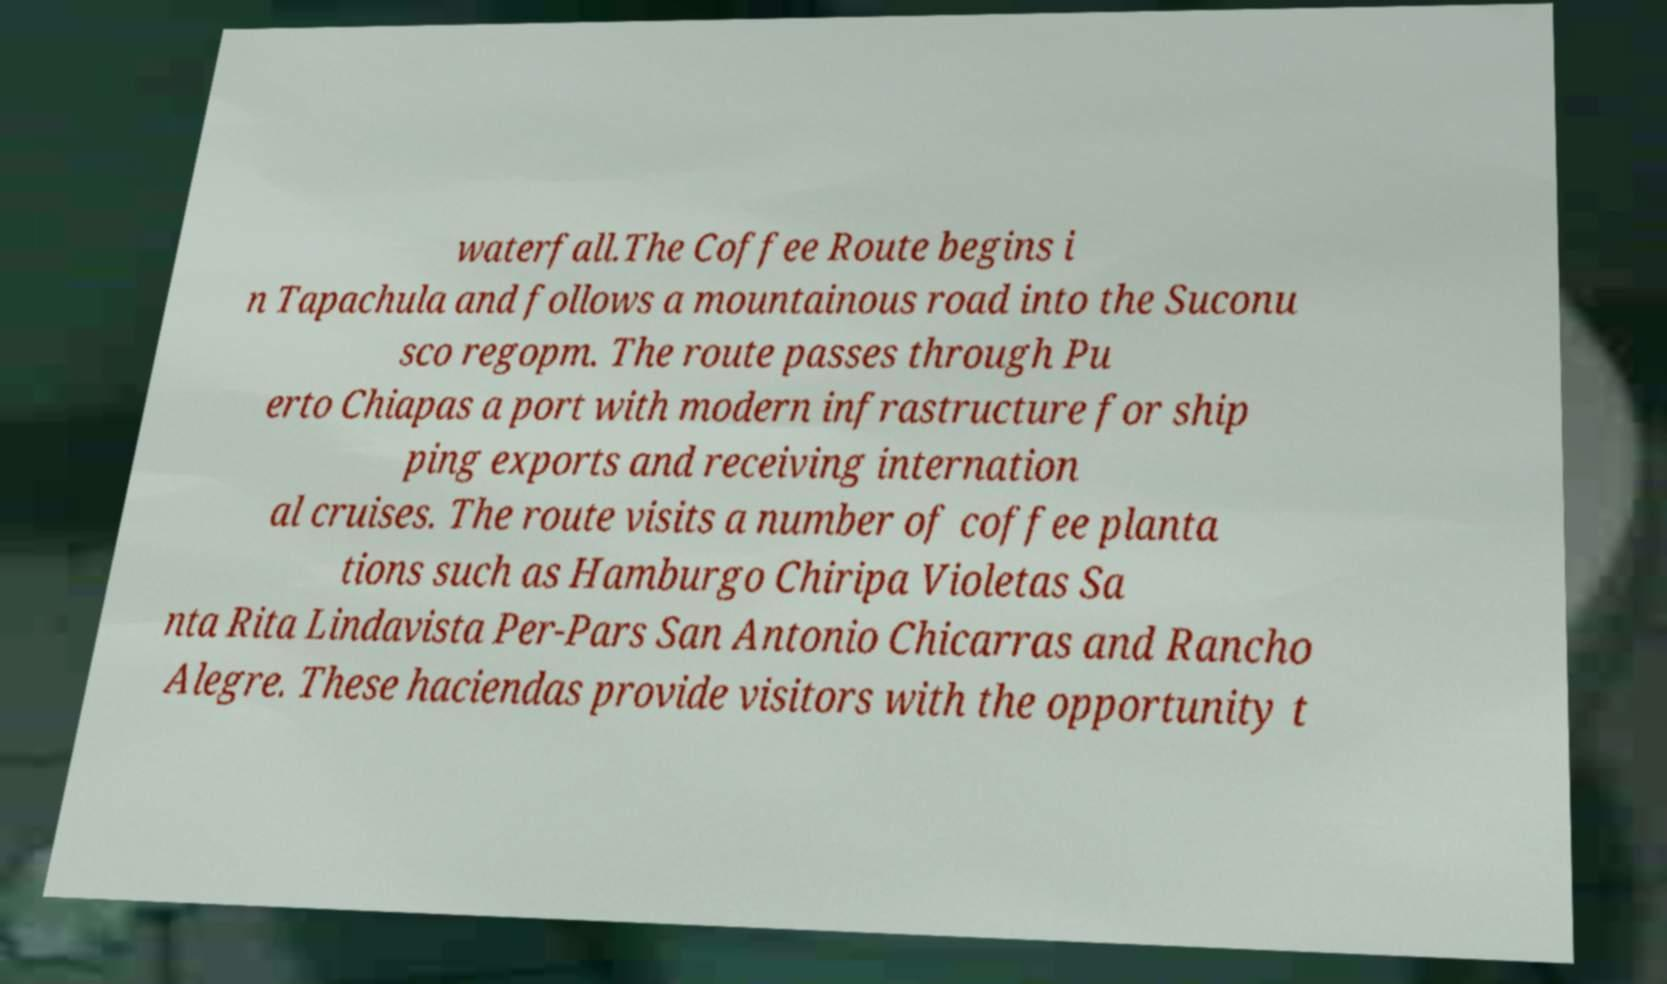Could you extract and type out the text from this image? waterfall.The Coffee Route begins i n Tapachula and follows a mountainous road into the Suconu sco regopm. The route passes through Pu erto Chiapas a port with modern infrastructure for ship ping exports and receiving internation al cruises. The route visits a number of coffee planta tions such as Hamburgo Chiripa Violetas Sa nta Rita Lindavista Per-Pars San Antonio Chicarras and Rancho Alegre. These haciendas provide visitors with the opportunity t 